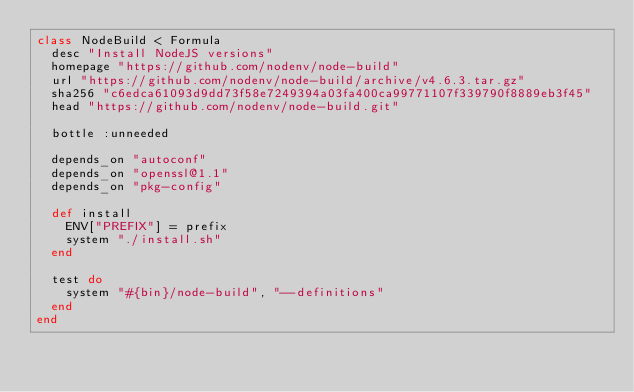Convert code to text. <code><loc_0><loc_0><loc_500><loc_500><_Ruby_>class NodeBuild < Formula
  desc "Install NodeJS versions"
  homepage "https://github.com/nodenv/node-build"
  url "https://github.com/nodenv/node-build/archive/v4.6.3.tar.gz"
  sha256 "c6edca61093d9dd73f58e7249394a03fa400ca99771107f339790f8889eb3f45"
  head "https://github.com/nodenv/node-build.git"

  bottle :unneeded

  depends_on "autoconf"
  depends_on "openssl@1.1"
  depends_on "pkg-config"

  def install
    ENV["PREFIX"] = prefix
    system "./install.sh"
  end

  test do
    system "#{bin}/node-build", "--definitions"
  end
end
</code> 